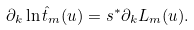Convert formula to latex. <formula><loc_0><loc_0><loc_500><loc_500>\partial _ { k } \ln \hat { t } _ { m } ( u ) = s ^ { * } \partial _ { k } L _ { m } ( u ) .</formula> 